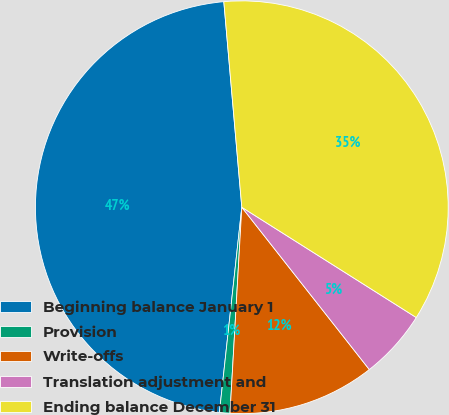Convert chart to OTSL. <chart><loc_0><loc_0><loc_500><loc_500><pie_chart><fcel>Beginning balance January 1<fcel>Provision<fcel>Write-offs<fcel>Translation adjustment and<fcel>Ending balance December 31<nl><fcel>46.88%<fcel>0.82%<fcel>11.51%<fcel>5.43%<fcel>35.36%<nl></chart> 